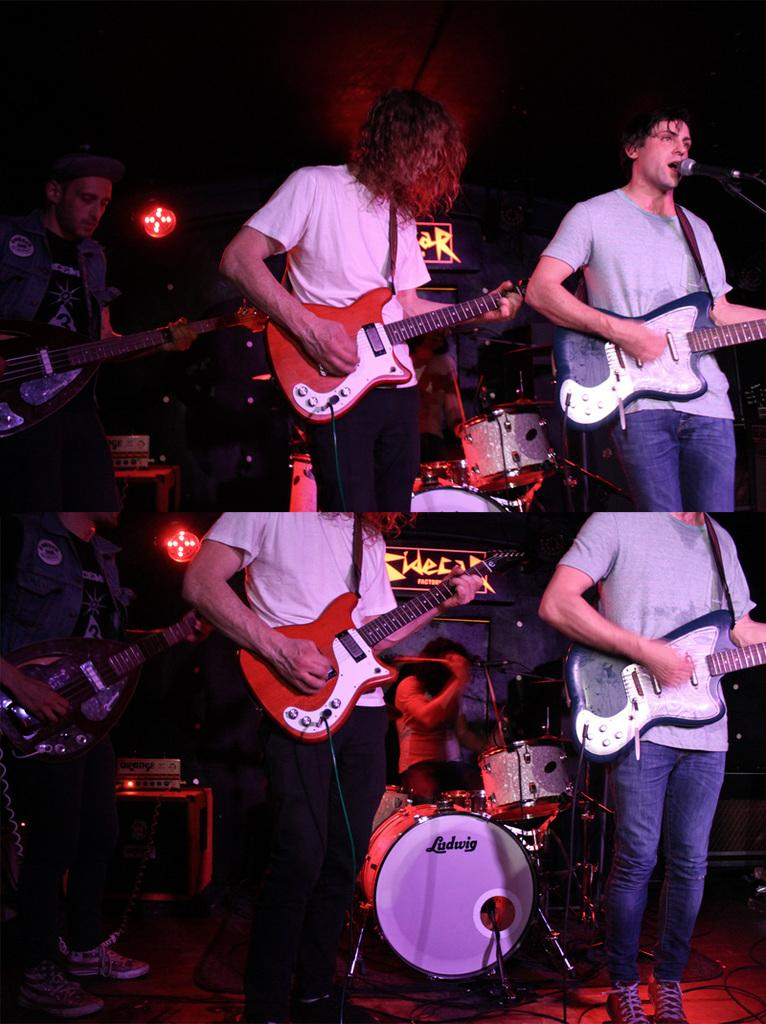What type of artwork is depicted in the image? The image is a collage. How many pictures are included in the collage? There are two pictures in the collage. What are the people in the pictures doing? In both pictures, there are people playing musical instruments. Are the sisters in the image playing the musical instruments together? There is no mention of sisters in the image, and the provided facts do not indicate that the people playing musical instruments are related. 